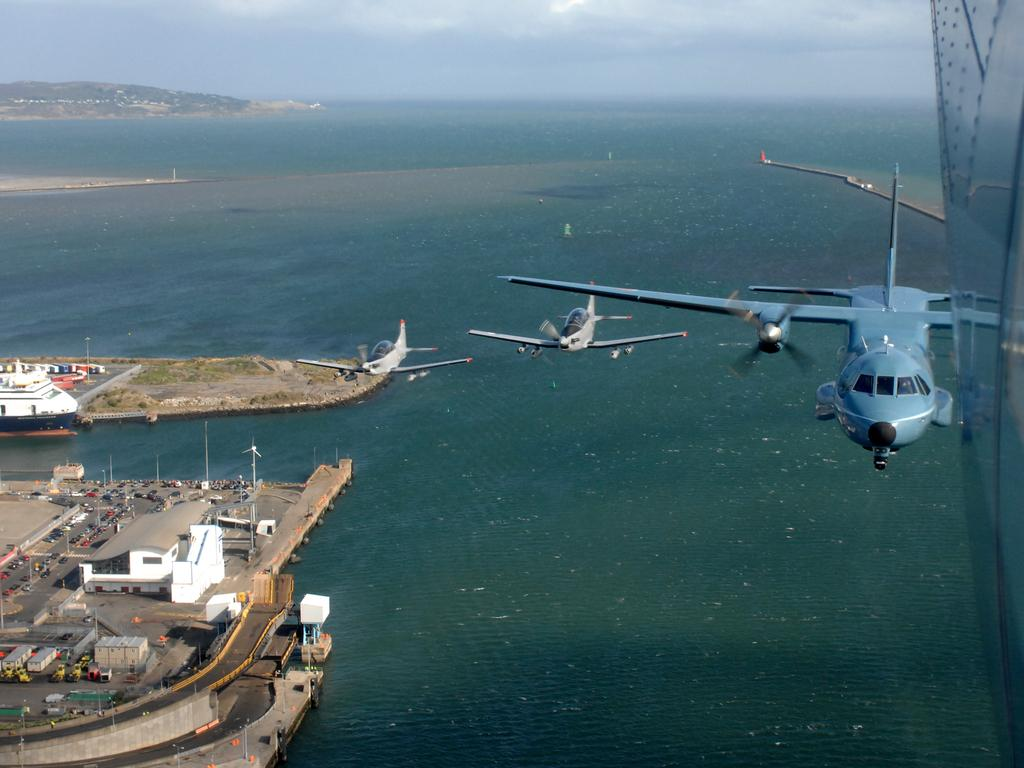What can be seen in the sky in the image? The sky with clouds is visible in the image. What type of natural landscape is present in the image? There are hills in the image. What large body of water is visible in the image? The ocean is present in the image. What type of transportation is in the air in the image? Aeroplanes are in the air in the image. What type of transportation is on the ground in the image? Motor vehicles are visible in the image. What type of structures are present in the image? There are sheds in the image. What type of watercraft is present in the image? Ships are present in the image. What type of man-made objects are visible in the image? Poles are visible in the image. Where are the grandmother's shoes located in the image? There are no shoes or grandmothers present in the image. What type of tool is the wrench used for in the image? There is no wrench present in the image. 